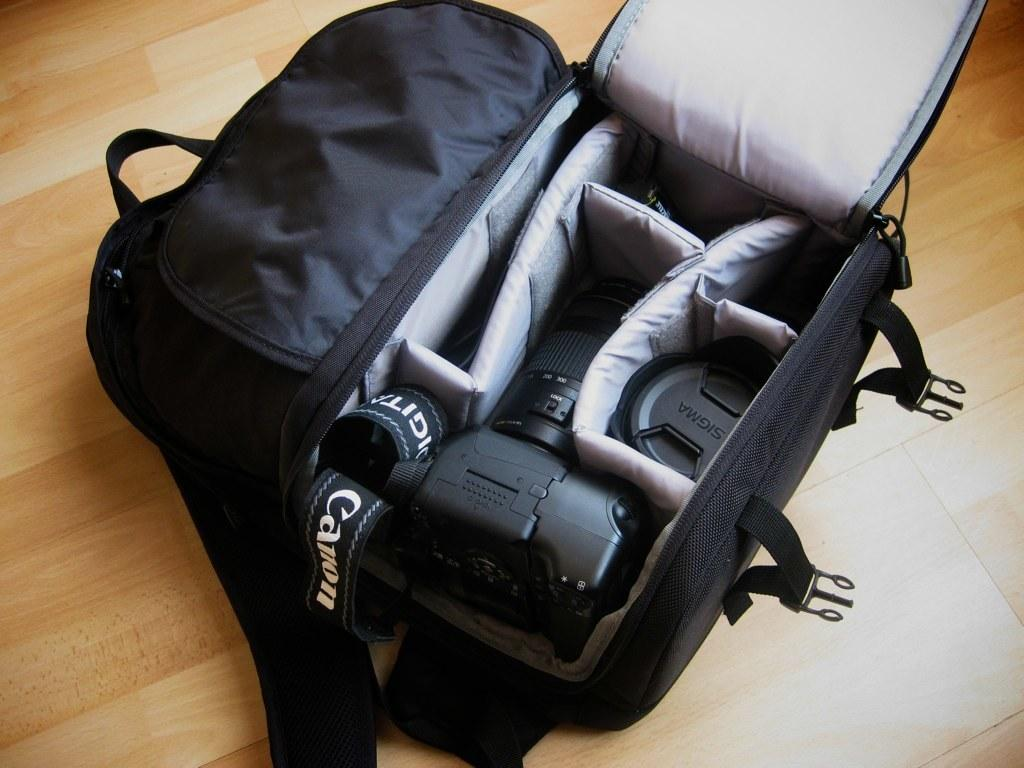What object is visible in the image? There is a bag in the image. What is inside the bag? A camera is placed inside the bag. What type of pie is being pushed on the table in the image? There is no pie or table present in the image; it only features a bag with a camera inside. 